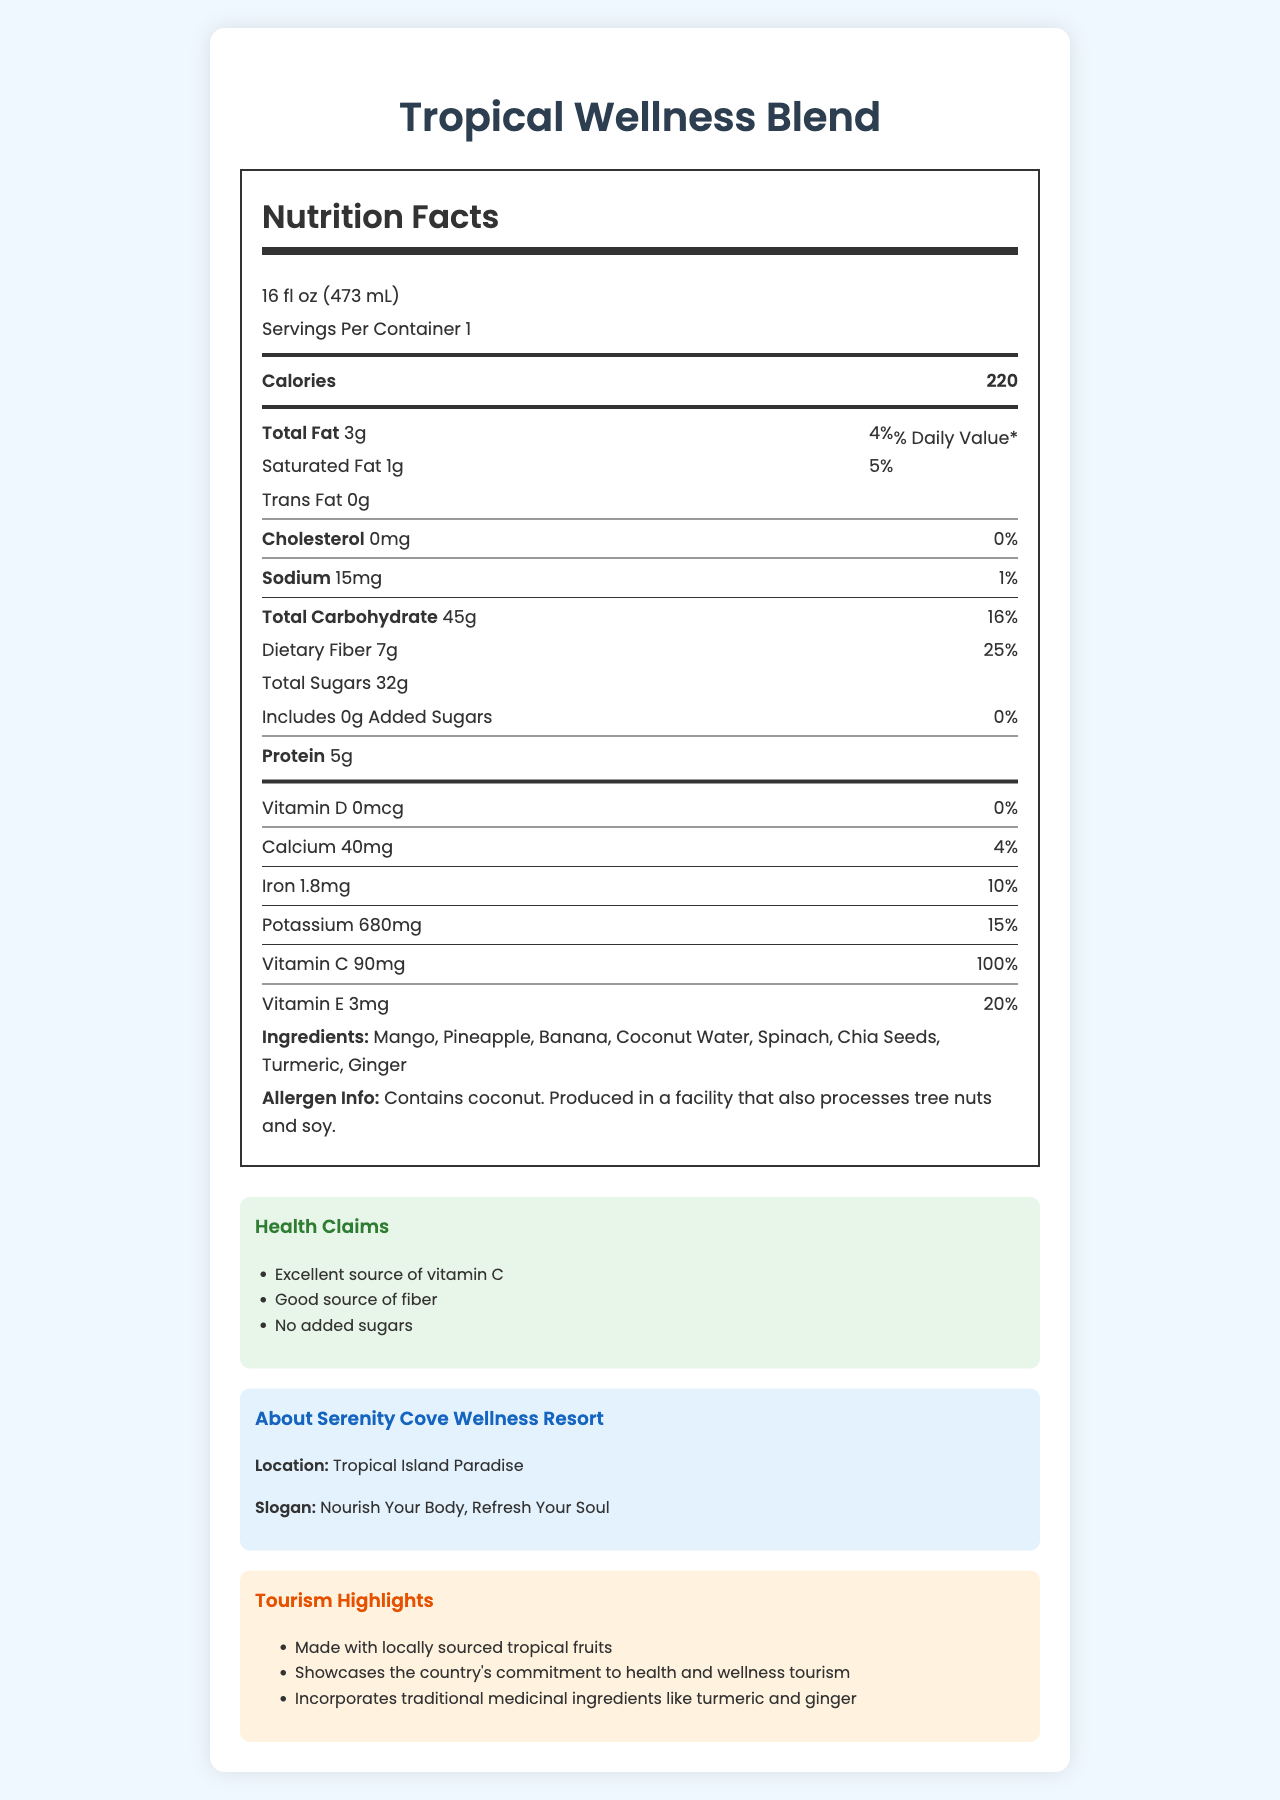what is the serving size? The serving size is clearly stated at the beginning of the nutrition facts section.
Answer: 16 fl oz (473 mL) how much dietary fiber is in one serving of the smoothie? The nutrition label indicates that there are 7g of dietary fiber per serving.
Answer: 7g what percentage of the daily value of calcium does one serving provide? The nutrition facts section shows that one serving provides 4% of the daily value for calcium.
Answer: 4% Which vitamin is present in the highest daily value percentage in the Tropical Wellness Blend? The label indicates that Vitamin C is present at 100% of the daily value, which is the highest among all the vitamins listed.
Answer: Vitamin C Does the Tropical Wellness Blend contain any added sugars? The nutrition facts label states that there are 0g of added sugars.
Answer: No what are the main ingredients in the Tropical Wellness Blend? These are listed under the ingredients section of the document.
Answer: Mango, Pineapple, Banana, Coconut Water, Spinach, Chia Seeds, Turmeric, Ginger How many calories are there in one serving of the Tropical Wellness Blend? The calorie count is prominently displayed in the nutrition facts section.
Answer: 220 What is the main slogan of Serenity Cove Wellness Resort? The resort's slogan is stated in the resort information section.
Answer: Nourish Your Body, Refresh Your Soul which of the following is NOT a tourism highlight of the Tropical Wellness Blend? A. Made with locally sourced tropical fruits B. Showcases the country's commitment to health and wellness tourism C. Incorporates traditional medicinal ingredients D. Contains added sugars The tourism highlights listed do not mention added sugars; in fact, the smoothie has no added sugars.
Answer: D. Contains added sugars What is the daily value percentage of potassium provided by the smoothie? A. 10% B. 15% C. 20% D. 25% The daily value percentage for potassium is 15%, as listed in the nutrition facts.
Answer: B. 15% Does the Tropical Wellness Blend contain any cholesterol? The label specifies that there is 0mg of cholesterol in the smoothie.
Answer: No Summarize the main idea of the document. The document serves to inform potential visitors about the nutritional benefits of the smoothie, aligning with the resort's emphasis on health and wellness.
Answer: The document provides a detailed nutrition facts label for the Tropical Wellness Blend, the signature smoothie of Serenity Cove Wellness Resort. It highlights the serving size, calories, macronutrient content, vitamins, and minerals, as well as the ingredients and health claims. Furthermore, it includes information about the resort and tourism highlights, emphasizing local sourcing and health benefits. Are there any allergens in the Tropical Wellness Blend? The label indicates that the smoothie contains coconut and is produced in a facility that also processes tree nuts and soy.
Answer: Yes what are the health claims made about the Tropical Wellness Blend? These claims are listed under the health claims section.
Answer: Excellent source of vitamin C, Good source of fiber, No added sugars What is the exact amount of protein in one serving of the Tropical Wellness Blend? The nutrition facts label shows that one serving contains 5g of protein.
Answer: 5g How many milligrams of vitamin D does the smoothie contain? The label indicates that there is no vitamin D in the smoothie.
Answer: 0mcg what is the total fat content in one serving of the Tropical Wellness Blend? A. 1g B. 3g C. 4g D. 5g The total fat content per serving is listed as 3g in the nutrition facts.
Answer: B. 3g How much iron does one serving of the smoothie provide? The nutrition label lists the iron content as 1.8mg per serving.
Answer: 1.8mg Is the Tropical Wellness Blend a good source of fiber? The smoothie has 7g of dietary fiber, which is 25% of the daily value, making it a good source of fiber according to the health claims section.
Answer: Yes what is the amount of sodium in one serving of the Tropical Wellness Blend? The label specifies that there are 15mg of sodium per serving.
Answer: 15mg who is the head chef at Serenity Cove Wellness Resort? The document does not provide any information about the head chef at Serenity Cove Wellness Resort.
Answer: I don't know 